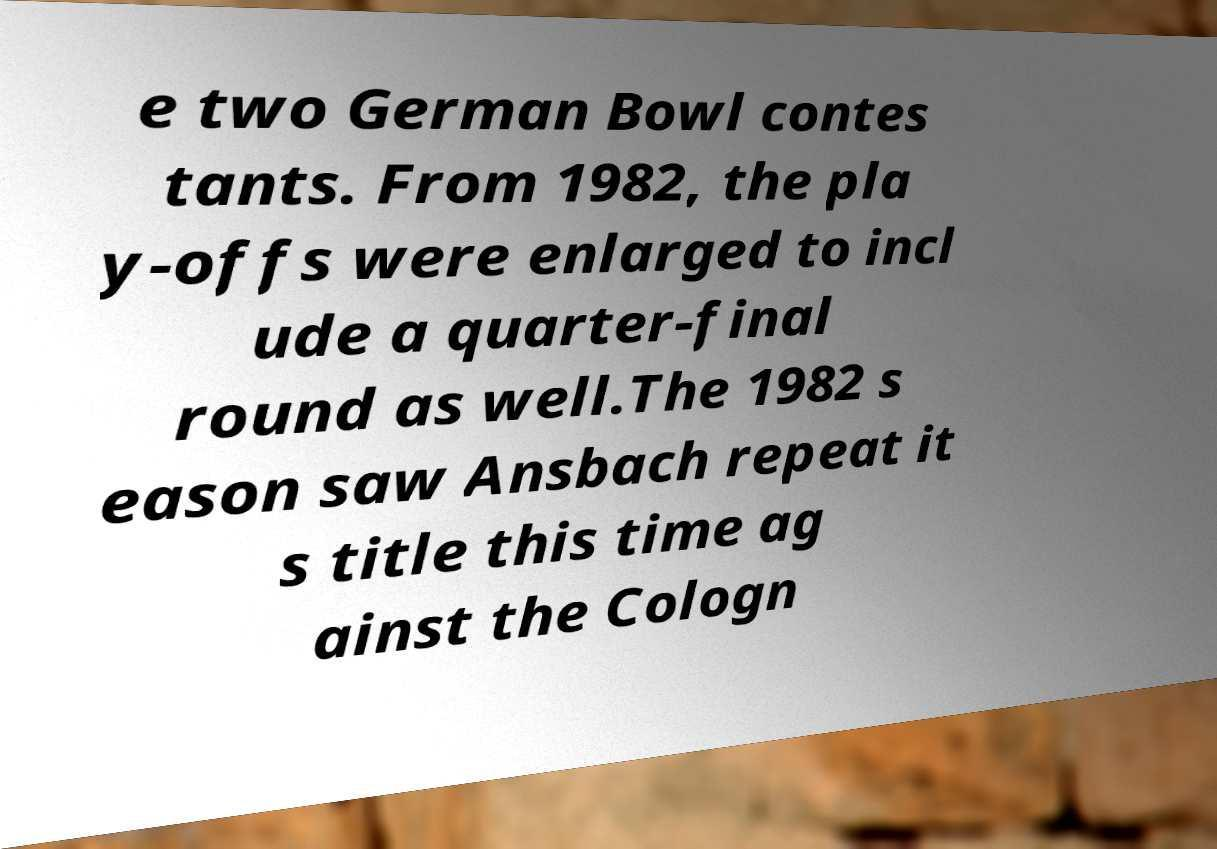Could you assist in decoding the text presented in this image and type it out clearly? e two German Bowl contes tants. From 1982, the pla y-offs were enlarged to incl ude a quarter-final round as well.The 1982 s eason saw Ansbach repeat it s title this time ag ainst the Cologn 